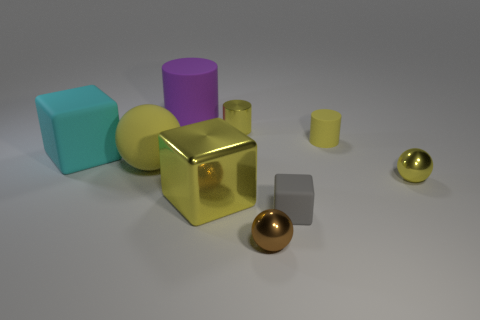What is the material of the yellow cylinder that is behind the rubber cylinder in front of the big purple thing? The yellow cylinder appears to have a reflective surface and resembles polished metal, likely brass or gold-colored aluminum, given its lustrous quality and color. 